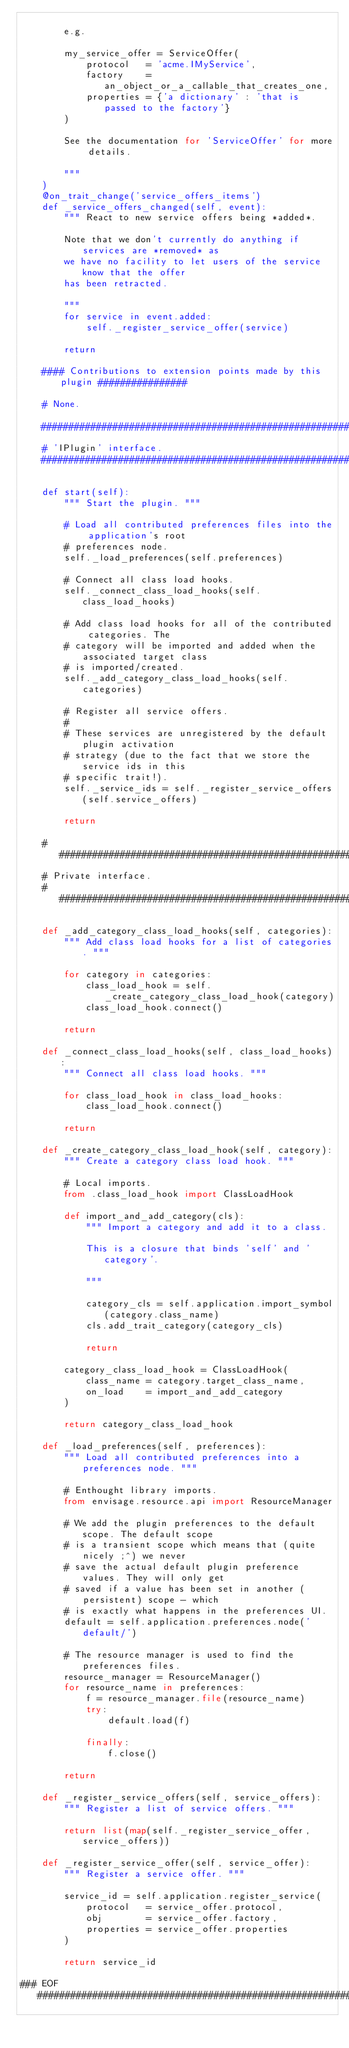<code> <loc_0><loc_0><loc_500><loc_500><_Python_>
        e.g.

        my_service_offer = ServiceOffer(
            protocol   = 'acme.IMyService',
            factory    = an_object_or_a_callable_that_creates_one,
            properties = {'a dictionary' : 'that is passed to the factory'}
        )

        See the documentation for 'ServiceOffer' for more details.

        """
    )
    @on_trait_change('service_offers_items')
    def _service_offers_changed(self, event):
        """ React to new service offers being *added*.

        Note that we don't currently do anything if services are *removed* as
        we have no facility to let users of the service know that the offer
        has been retracted.

        """
        for service in event.added:
            self._register_service_offer(service)

        return

    #### Contributions to extension points made by this plugin ################

    # None.

    ###########################################################################
    # 'IPlugin' interface.
    ###########################################################################

    def start(self):
        """ Start the plugin. """

        # Load all contributed preferences files into the application's root
        # preferences node.
        self._load_preferences(self.preferences)

        # Connect all class load hooks.
        self._connect_class_load_hooks(self.class_load_hooks)

        # Add class load hooks for all of the contributed categories. The
        # category will be imported and added when the associated target class
        # is imported/created.
        self._add_category_class_load_hooks(self.categories)

        # Register all service offers.
        #
        # These services are unregistered by the default plugin activation
        # strategy (due to the fact that we store the service ids in this
        # specific trait!).
        self._service_ids = self._register_service_offers(self.service_offers)

        return

    ###########################################################################
    # Private interface.
    ###########################################################################

    def _add_category_class_load_hooks(self, categories):
        """ Add class load hooks for a list of categories. """

        for category in categories:
            class_load_hook = self._create_category_class_load_hook(category)
            class_load_hook.connect()

        return

    def _connect_class_load_hooks(self, class_load_hooks):
        """ Connect all class load hooks. """

        for class_load_hook in class_load_hooks:
            class_load_hook.connect()

        return

    def _create_category_class_load_hook(self, category):
        """ Create a category class load hook. """

        # Local imports.
        from .class_load_hook import ClassLoadHook

        def import_and_add_category(cls):
            """ Import a category and add it to a class.

            This is a closure that binds 'self' and 'category'.

            """

            category_cls = self.application.import_symbol(category.class_name)
            cls.add_trait_category(category_cls)

            return

        category_class_load_hook = ClassLoadHook(
            class_name = category.target_class_name,
            on_load    = import_and_add_category
        )

        return category_class_load_hook

    def _load_preferences(self, preferences):
        """ Load all contributed preferences into a preferences node. """

        # Enthought library imports.
        from envisage.resource.api import ResourceManager

        # We add the plugin preferences to the default scope. The default scope
        # is a transient scope which means that (quite nicely ;^) we never
        # save the actual default plugin preference values. They will only get
        # saved if a value has been set in another (persistent) scope - which
        # is exactly what happens in the preferences UI.
        default = self.application.preferences.node('default/')

        # The resource manager is used to find the preferences files.
        resource_manager = ResourceManager()
        for resource_name in preferences:
            f = resource_manager.file(resource_name)
            try:
                default.load(f)

            finally:
                f.close()

        return

    def _register_service_offers(self, service_offers):
        """ Register a list of service offers. """

        return list(map(self._register_service_offer, service_offers))

    def _register_service_offer(self, service_offer):
        """ Register a service offer. """

        service_id = self.application.register_service(
            protocol   = service_offer.protocol,
            obj        = service_offer.factory,
            properties = service_offer.properties
        )

        return service_id

### EOF ######################################################################
</code> 